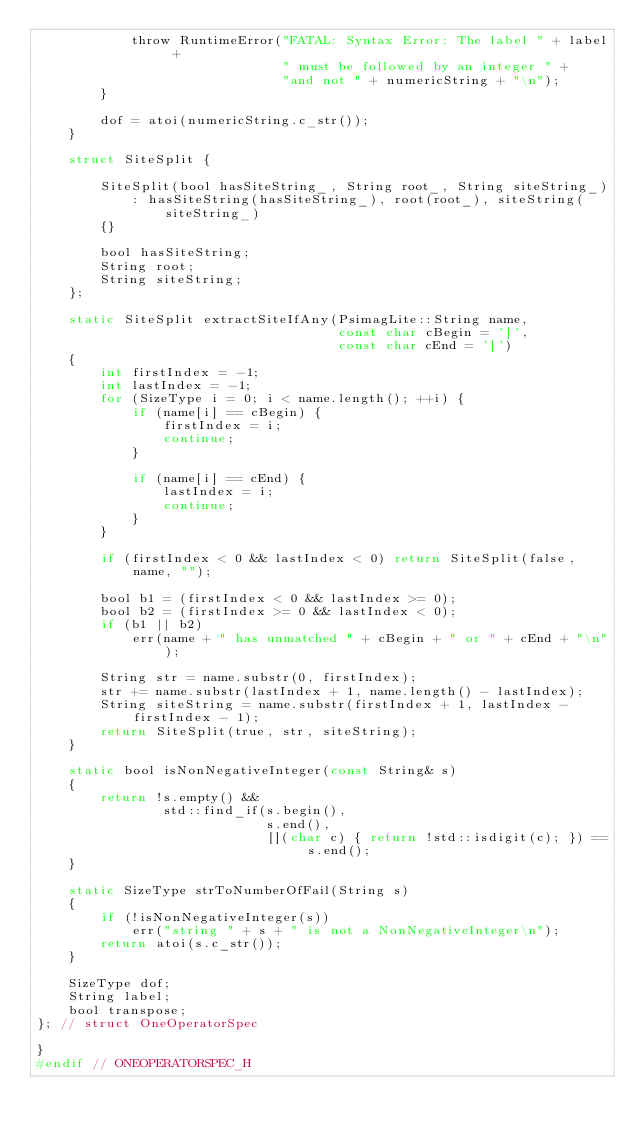Convert code to text. <code><loc_0><loc_0><loc_500><loc_500><_C_>			throw RuntimeError("FATAL: Syntax Error: The label " + label +
			                   " must be followed by an integer " +
			                   "and not " + numericString + "\n");
		}

		dof = atoi(numericString.c_str());
	}

	struct SiteSplit {

		SiteSplit(bool hasSiteString_, String root_, String siteString_)
		    : hasSiteString(hasSiteString_), root(root_), siteString(siteString_)
		{}

		bool hasSiteString;
		String root;
		String siteString;
	};

	static SiteSplit extractSiteIfAny(PsimagLite::String name,
	                                  const char cBegin = '[',
	                                  const char cEnd = ']')
	{
		int firstIndex = -1;
		int lastIndex = -1;
		for (SizeType i = 0; i < name.length(); ++i) {
			if (name[i] == cBegin) {
				firstIndex = i;
				continue;
			}

			if (name[i] == cEnd) {
				lastIndex = i;
				continue;
			}
		}

		if (firstIndex < 0 && lastIndex < 0) return SiteSplit(false, name, "");

		bool b1 = (firstIndex < 0 && lastIndex >= 0);
		bool b2 = (firstIndex >= 0 && lastIndex < 0);
		if (b1 || b2)
			err(name + " has unmatched " + cBegin + " or " + cEnd + "\n");

		String str = name.substr(0, firstIndex);
		str += name.substr(lastIndex + 1, name.length() - lastIndex);
		String siteString = name.substr(firstIndex + 1, lastIndex - firstIndex - 1);
		return SiteSplit(true, str, siteString);
	}

	static bool isNonNegativeInteger(const String& s)
	{
		return !s.empty() &&
		        std::find_if(s.begin(),
		                     s.end(),
		                     [](char c) { return !std::isdigit(c); }) == s.end();
	}

	static SizeType strToNumberOfFail(String s)
	{
		if (!isNonNegativeInteger(s))
			err("string " + s + " is not a NonNegativeInteger\n");
		return atoi(s.c_str());
	}

	SizeType dof;
	String label;
	bool transpose;
}; // struct OneOperatorSpec

}
#endif // ONEOPERATORSPEC_H
</code> 